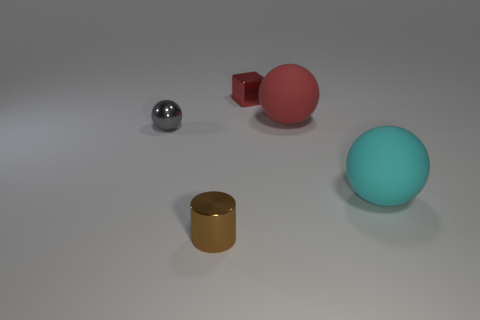Add 1 metal balls. How many objects exist? 6 Subtract all blocks. How many objects are left? 4 Subtract all tiny brown metallic cylinders. Subtract all red shiny objects. How many objects are left? 3 Add 1 cyan spheres. How many cyan spheres are left? 2 Add 3 purple shiny things. How many purple shiny things exist? 3 Subtract 0 blue cubes. How many objects are left? 5 